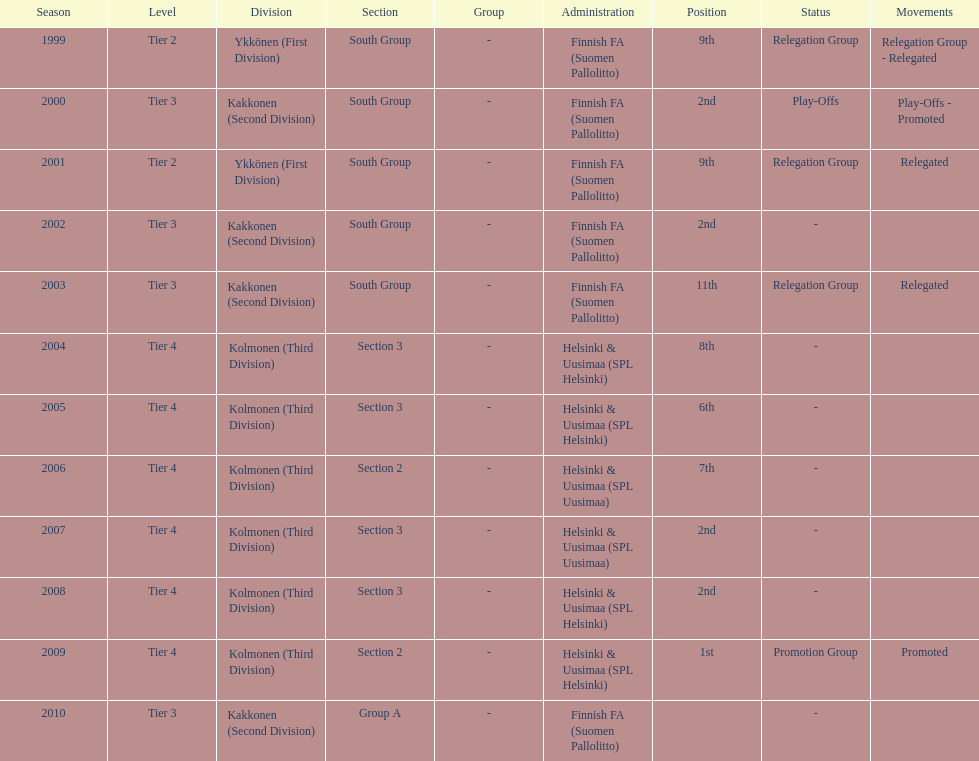How many times were they in tier 3? 4. 